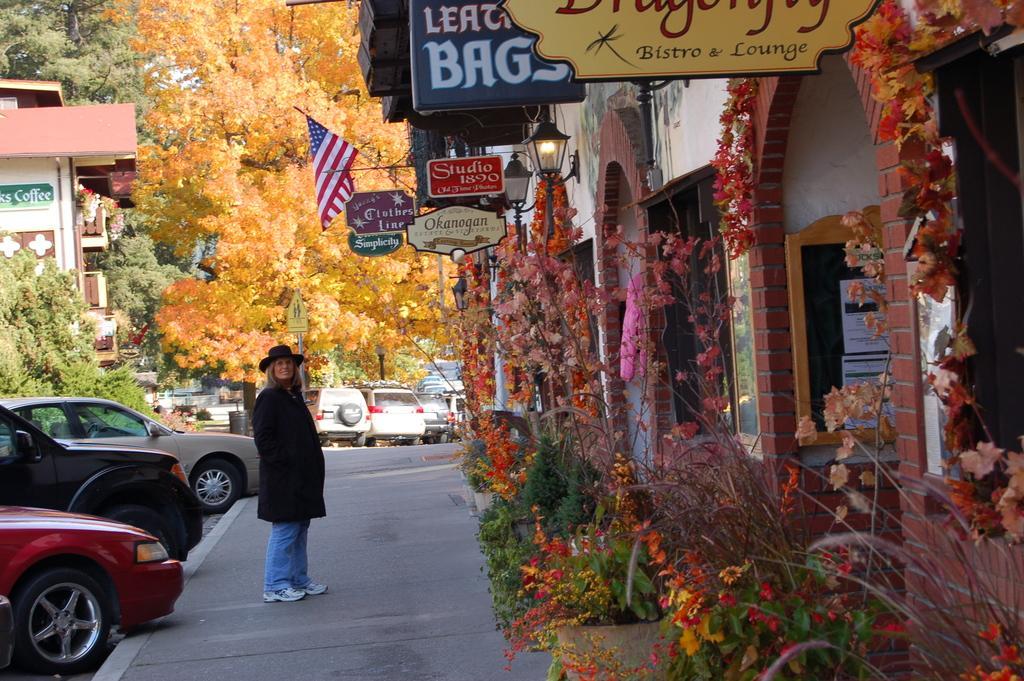Can you describe this image briefly? In the bottom right side of the image there are some plants and flowers. Behind them there is a building, on the building there are some lights and flags and banners. In the middle of the image a woman is standing and watching. Behind her there are some vehicles and poles and trees and buildings. 